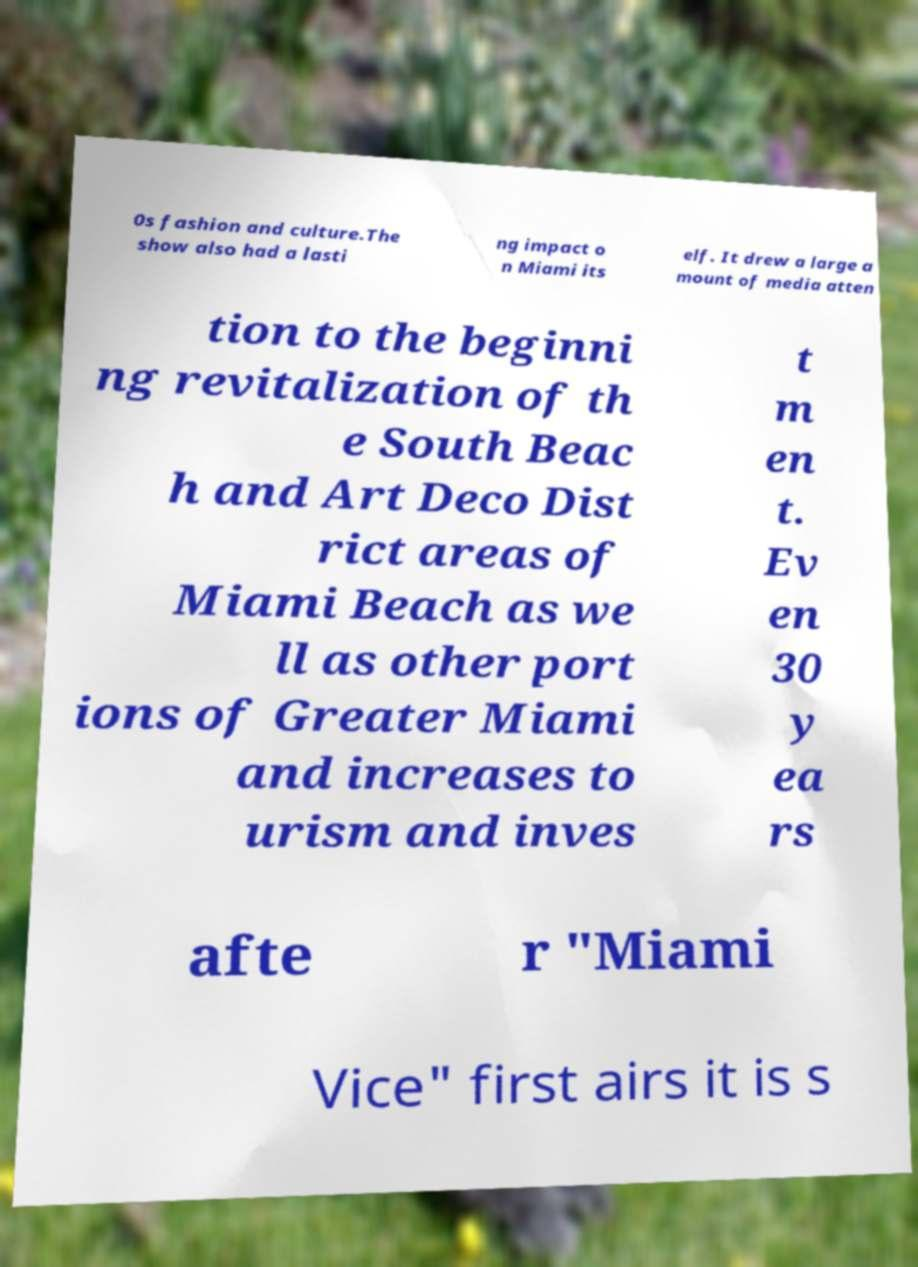Could you assist in decoding the text presented in this image and type it out clearly? 0s fashion and culture.The show also had a lasti ng impact o n Miami its elf. It drew a large a mount of media atten tion to the beginni ng revitalization of th e South Beac h and Art Deco Dist rict areas of Miami Beach as we ll as other port ions of Greater Miami and increases to urism and inves t m en t. Ev en 30 y ea rs afte r "Miami Vice" first airs it is s 